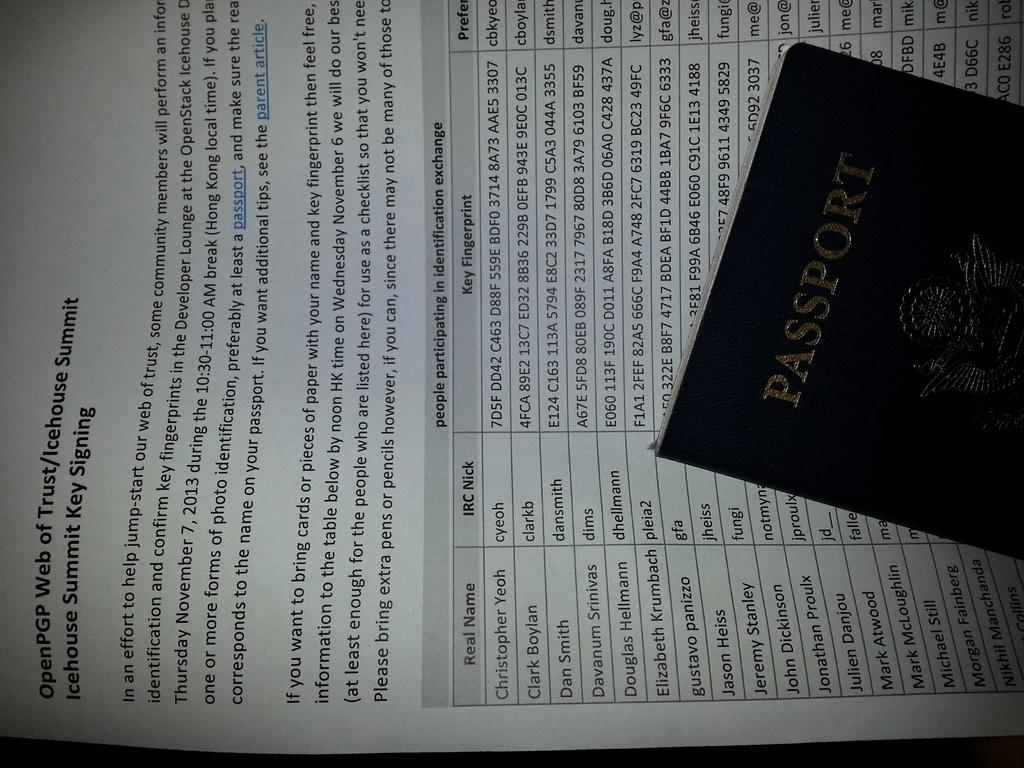<image>
Write a terse but informative summary of the picture. A passport lies on top of a page about the OpenPGP Web of Trust. 